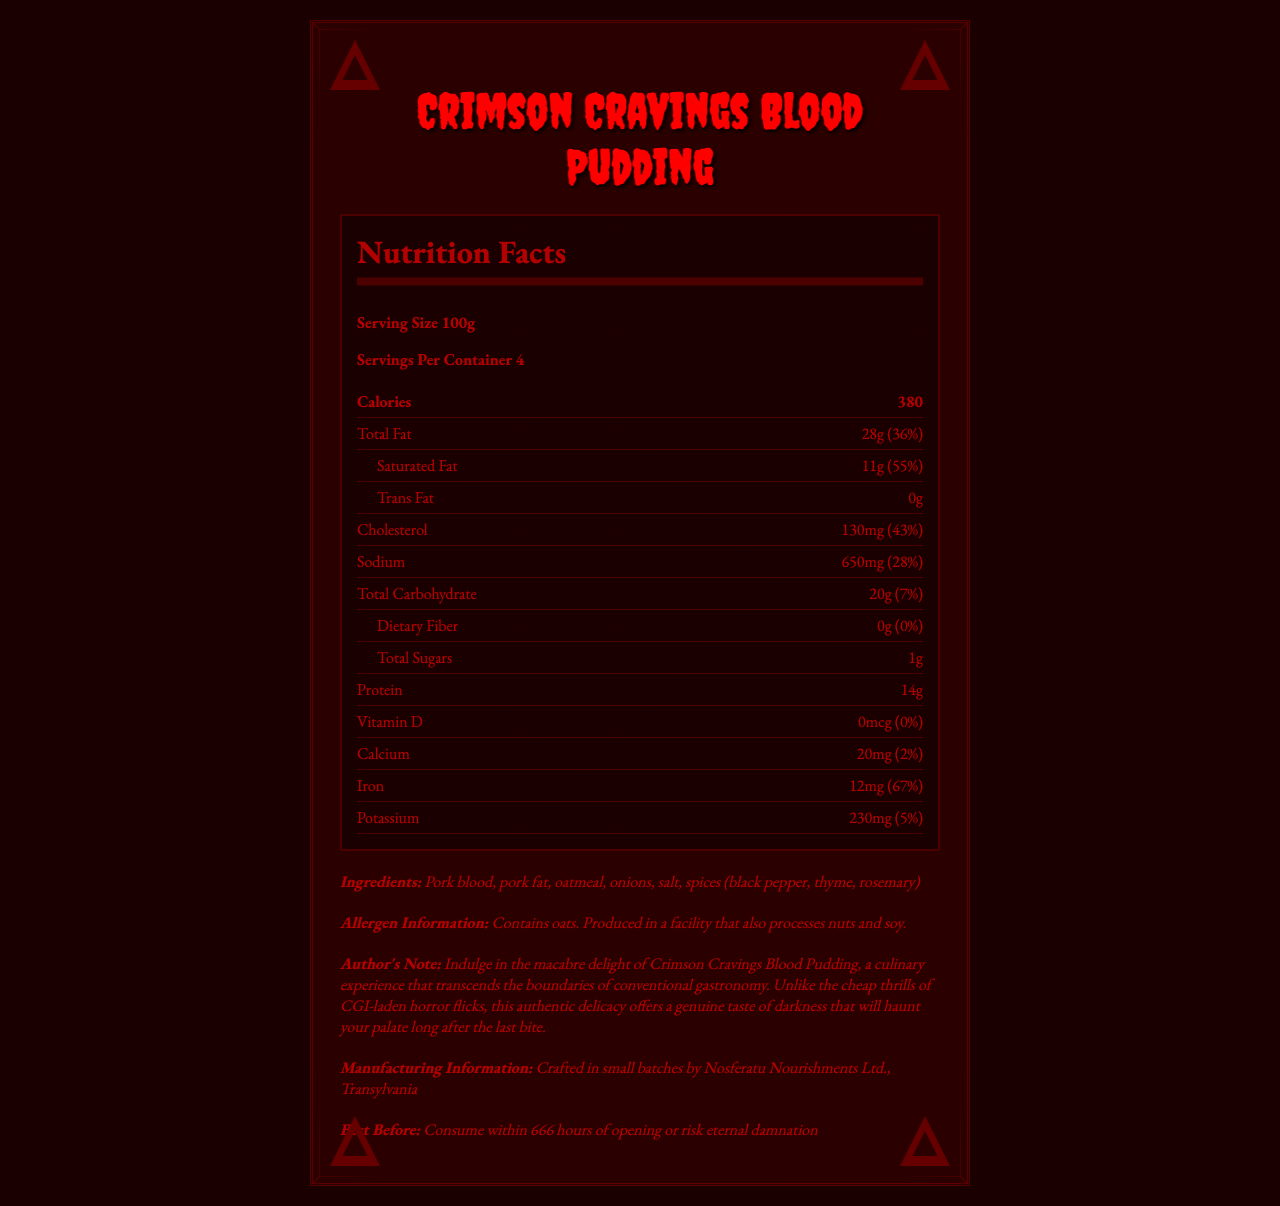what is the serving size? The label mentions the serving size as 100g.
Answer: 100g how many servings are there per container? The label indicates that there are four servings per container.
Answer: 4 how much total fat is in one serving? According to the nutrition facts, one serving of blood pudding has 28g of total fat.
Answer: 28g what is the daily value percentage for saturated fat? The document shows that the daily value percentage for saturated fat is 55%.
Answer: 55% list all the ingredients in this product. The ingredients are listed in the section beneath "Ingredients:".
Answer: Pork blood, pork fat, oatmeal, onions, salt, spices (black pepper, thyme, rosemary) how many calories are in a single serving? The label states that there are 380 calories in a single serving of blood pudding.
Answer: 380 what amount of cholesterol does one serving contain? The label indicates that one serving contains 130mg of cholesterol.
Answer: 130mg what company manufactures this blood pudding? The manufacturing information reveals that Nosferatu Nourishments Ltd. in Transylvania makes the product.
Answer: Nosferatu Nourishments Ltd., Transylvania what type of design elements are included in the label? The document details the various gothic design elements used in the label.
Answer: Victorian-style ornate border with bat motifs, dark crimson background with black text, dripping blood font for product name, gargoyle silhouettes in corners, spiderweb patterns behind nutritional values what is the best before time for the blood pudding? The best before section advises to consume within 666 hours of opening or risk eternal damnation.
Answer: Consume within 666 hours of opening or risk eternal damnation how much protein is in one serving? The nutrition facts section lists 14g of protein per serving.
Answer: 14g what daily value percentage of iron is in a single serving? The label shows that the daily value percentage for iron is 67%.
Answer: 67% how much dietary fiber is in one serving of the blood pudding? A. 0g B. 1g C. 2g D. 5g The document states that there is 0g of dietary fiber in one serving.
Answer: A. 0g which of the following is not listed as an allergen in the blood pudding? I. Oats II. Soy III. Dairy IV. Nuts The allergen information section mentions oats, nuts, and soy, but does not list dairy as an allergen.
Answer: III. Dairy what is described as a culinary experience that transcends conventional gastronomy? A. Blood Pudding B. Pork C. Black Pepper D. Thyme The author's note describes the blood pudding as a culinary experience that transcends conventional gastronomy.
Answer: A. Blood Pudding does the product contain vitamin D? The nutrition facts show that the amount of vitamin D is 0mcg with a daily value of 0%.
Answer: No summarize the main idea of this document. The document provides comprehensive details about the nutrition facts, ingredients, allergen information, and gothic design elements of Crimson Cravings Blood Pudding, along with a note from the author.
Answer: Crimson Cravings Blood Pudding is a savory product with rich gothic design elements, detailed nutritional information, and a unique author's note emphasizing its authentic and haunting culinary experience. what is the exact amount of oatmeal used in the ingredients? The document lists oatmeal as an ingredient but does not specify the exact amount used.
Answer: Cannot be determined 